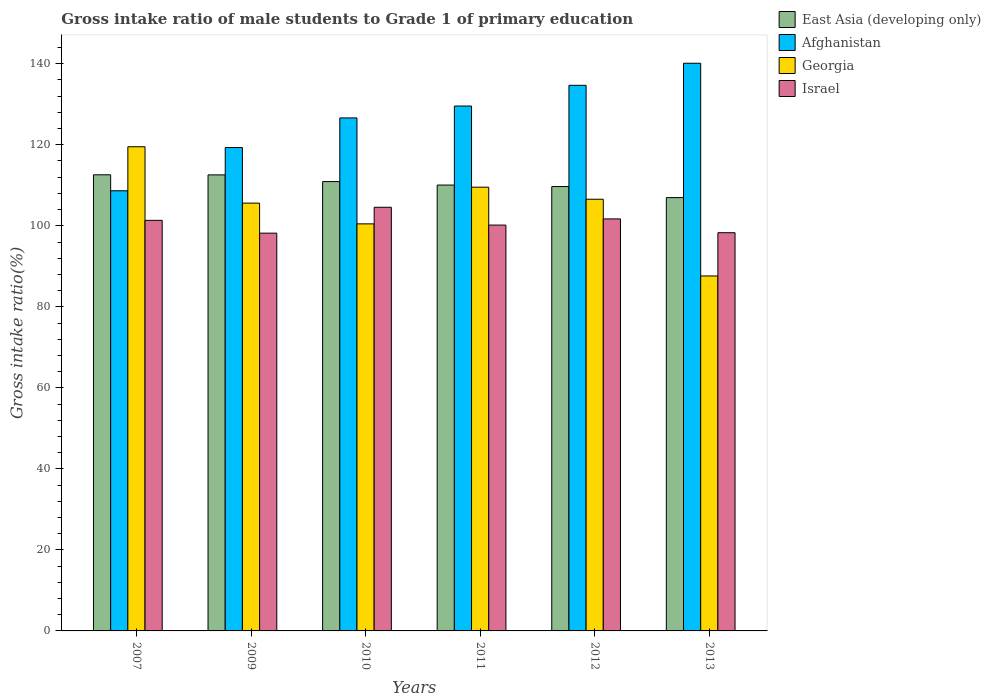How many different coloured bars are there?
Provide a succinct answer. 4. How many groups of bars are there?
Keep it short and to the point. 6. Are the number of bars per tick equal to the number of legend labels?
Ensure brevity in your answer.  Yes. Are the number of bars on each tick of the X-axis equal?
Keep it short and to the point. Yes. How many bars are there on the 1st tick from the right?
Provide a short and direct response. 4. What is the gross intake ratio in Georgia in 2012?
Make the answer very short. 106.55. Across all years, what is the maximum gross intake ratio in Israel?
Offer a very short reply. 104.58. Across all years, what is the minimum gross intake ratio in Afghanistan?
Offer a very short reply. 108.65. What is the total gross intake ratio in Georgia in the graph?
Offer a terse response. 629.29. What is the difference between the gross intake ratio in Afghanistan in 2009 and that in 2012?
Offer a terse response. -15.37. What is the difference between the gross intake ratio in East Asia (developing only) in 2007 and the gross intake ratio in Georgia in 2010?
Keep it short and to the point. 12.12. What is the average gross intake ratio in Israel per year?
Give a very brief answer. 100.71. In the year 2012, what is the difference between the gross intake ratio in East Asia (developing only) and gross intake ratio in Afghanistan?
Your response must be concise. -24.99. In how many years, is the gross intake ratio in East Asia (developing only) greater than 12 %?
Offer a terse response. 6. What is the ratio of the gross intake ratio in Afghanistan in 2007 to that in 2009?
Your answer should be compact. 0.91. Is the gross intake ratio in Afghanistan in 2007 less than that in 2009?
Make the answer very short. Yes. Is the difference between the gross intake ratio in East Asia (developing only) in 2007 and 2009 greater than the difference between the gross intake ratio in Afghanistan in 2007 and 2009?
Provide a succinct answer. Yes. What is the difference between the highest and the second highest gross intake ratio in Israel?
Give a very brief answer. 2.87. What is the difference between the highest and the lowest gross intake ratio in East Asia (developing only)?
Give a very brief answer. 5.64. In how many years, is the gross intake ratio in Afghanistan greater than the average gross intake ratio in Afghanistan taken over all years?
Ensure brevity in your answer.  4. Is the sum of the gross intake ratio in Afghanistan in 2012 and 2013 greater than the maximum gross intake ratio in East Asia (developing only) across all years?
Your answer should be very brief. Yes. What does the 4th bar from the right in 2011 represents?
Offer a terse response. East Asia (developing only). Does the graph contain any zero values?
Your answer should be very brief. No. Does the graph contain grids?
Offer a very short reply. No. What is the title of the graph?
Provide a succinct answer. Gross intake ratio of male students to Grade 1 of primary education. Does "Vietnam" appear as one of the legend labels in the graph?
Offer a terse response. No. What is the label or title of the Y-axis?
Offer a very short reply. Gross intake ratio(%). What is the Gross intake ratio(%) of East Asia (developing only) in 2007?
Provide a succinct answer. 112.59. What is the Gross intake ratio(%) in Afghanistan in 2007?
Provide a succinct answer. 108.65. What is the Gross intake ratio(%) of Georgia in 2007?
Provide a short and direct response. 119.51. What is the Gross intake ratio(%) of Israel in 2007?
Provide a short and direct response. 101.34. What is the Gross intake ratio(%) of East Asia (developing only) in 2009?
Your answer should be very brief. 112.57. What is the Gross intake ratio(%) in Afghanistan in 2009?
Keep it short and to the point. 119.31. What is the Gross intake ratio(%) in Georgia in 2009?
Ensure brevity in your answer.  105.6. What is the Gross intake ratio(%) of Israel in 2009?
Provide a succinct answer. 98.19. What is the Gross intake ratio(%) in East Asia (developing only) in 2010?
Offer a very short reply. 110.91. What is the Gross intake ratio(%) in Afghanistan in 2010?
Offer a terse response. 126.63. What is the Gross intake ratio(%) in Georgia in 2010?
Offer a terse response. 100.48. What is the Gross intake ratio(%) in Israel in 2010?
Your answer should be compact. 104.58. What is the Gross intake ratio(%) of East Asia (developing only) in 2011?
Provide a succinct answer. 110.06. What is the Gross intake ratio(%) in Afghanistan in 2011?
Offer a terse response. 129.57. What is the Gross intake ratio(%) in Georgia in 2011?
Offer a very short reply. 109.53. What is the Gross intake ratio(%) in Israel in 2011?
Keep it short and to the point. 100.18. What is the Gross intake ratio(%) of East Asia (developing only) in 2012?
Keep it short and to the point. 109.69. What is the Gross intake ratio(%) in Afghanistan in 2012?
Your answer should be very brief. 134.68. What is the Gross intake ratio(%) of Georgia in 2012?
Provide a succinct answer. 106.55. What is the Gross intake ratio(%) of Israel in 2012?
Give a very brief answer. 101.7. What is the Gross intake ratio(%) in East Asia (developing only) in 2013?
Ensure brevity in your answer.  106.96. What is the Gross intake ratio(%) in Afghanistan in 2013?
Keep it short and to the point. 140.12. What is the Gross intake ratio(%) in Georgia in 2013?
Make the answer very short. 87.62. What is the Gross intake ratio(%) of Israel in 2013?
Provide a succinct answer. 98.29. Across all years, what is the maximum Gross intake ratio(%) of East Asia (developing only)?
Make the answer very short. 112.59. Across all years, what is the maximum Gross intake ratio(%) of Afghanistan?
Your answer should be very brief. 140.12. Across all years, what is the maximum Gross intake ratio(%) in Georgia?
Your response must be concise. 119.51. Across all years, what is the maximum Gross intake ratio(%) of Israel?
Make the answer very short. 104.58. Across all years, what is the minimum Gross intake ratio(%) of East Asia (developing only)?
Your response must be concise. 106.96. Across all years, what is the minimum Gross intake ratio(%) of Afghanistan?
Your answer should be compact. 108.65. Across all years, what is the minimum Gross intake ratio(%) of Georgia?
Your response must be concise. 87.62. Across all years, what is the minimum Gross intake ratio(%) in Israel?
Ensure brevity in your answer.  98.19. What is the total Gross intake ratio(%) in East Asia (developing only) in the graph?
Provide a succinct answer. 662.77. What is the total Gross intake ratio(%) of Afghanistan in the graph?
Provide a short and direct response. 758.96. What is the total Gross intake ratio(%) in Georgia in the graph?
Provide a short and direct response. 629.29. What is the total Gross intake ratio(%) of Israel in the graph?
Provide a short and direct response. 604.28. What is the difference between the Gross intake ratio(%) of East Asia (developing only) in 2007 and that in 2009?
Ensure brevity in your answer.  0.02. What is the difference between the Gross intake ratio(%) in Afghanistan in 2007 and that in 2009?
Provide a short and direct response. -10.67. What is the difference between the Gross intake ratio(%) of Georgia in 2007 and that in 2009?
Provide a short and direct response. 13.91. What is the difference between the Gross intake ratio(%) of Israel in 2007 and that in 2009?
Provide a succinct answer. 3.16. What is the difference between the Gross intake ratio(%) in East Asia (developing only) in 2007 and that in 2010?
Your response must be concise. 1.68. What is the difference between the Gross intake ratio(%) of Afghanistan in 2007 and that in 2010?
Provide a short and direct response. -17.98. What is the difference between the Gross intake ratio(%) in Georgia in 2007 and that in 2010?
Ensure brevity in your answer.  19.04. What is the difference between the Gross intake ratio(%) of Israel in 2007 and that in 2010?
Keep it short and to the point. -3.23. What is the difference between the Gross intake ratio(%) of East Asia (developing only) in 2007 and that in 2011?
Offer a very short reply. 2.54. What is the difference between the Gross intake ratio(%) of Afghanistan in 2007 and that in 2011?
Provide a succinct answer. -20.92. What is the difference between the Gross intake ratio(%) of Georgia in 2007 and that in 2011?
Your answer should be compact. 9.98. What is the difference between the Gross intake ratio(%) in Israel in 2007 and that in 2011?
Make the answer very short. 1.16. What is the difference between the Gross intake ratio(%) of East Asia (developing only) in 2007 and that in 2012?
Provide a succinct answer. 2.91. What is the difference between the Gross intake ratio(%) of Afghanistan in 2007 and that in 2012?
Your answer should be compact. -26.03. What is the difference between the Gross intake ratio(%) in Georgia in 2007 and that in 2012?
Keep it short and to the point. 12.96. What is the difference between the Gross intake ratio(%) of Israel in 2007 and that in 2012?
Ensure brevity in your answer.  -0.36. What is the difference between the Gross intake ratio(%) of East Asia (developing only) in 2007 and that in 2013?
Give a very brief answer. 5.64. What is the difference between the Gross intake ratio(%) in Afghanistan in 2007 and that in 2013?
Make the answer very short. -31.47. What is the difference between the Gross intake ratio(%) in Georgia in 2007 and that in 2013?
Offer a terse response. 31.89. What is the difference between the Gross intake ratio(%) in Israel in 2007 and that in 2013?
Ensure brevity in your answer.  3.05. What is the difference between the Gross intake ratio(%) in East Asia (developing only) in 2009 and that in 2010?
Provide a short and direct response. 1.66. What is the difference between the Gross intake ratio(%) in Afghanistan in 2009 and that in 2010?
Your response must be concise. -7.32. What is the difference between the Gross intake ratio(%) in Georgia in 2009 and that in 2010?
Provide a short and direct response. 5.12. What is the difference between the Gross intake ratio(%) of Israel in 2009 and that in 2010?
Ensure brevity in your answer.  -6.39. What is the difference between the Gross intake ratio(%) of East Asia (developing only) in 2009 and that in 2011?
Give a very brief answer. 2.51. What is the difference between the Gross intake ratio(%) of Afghanistan in 2009 and that in 2011?
Provide a succinct answer. -10.25. What is the difference between the Gross intake ratio(%) of Georgia in 2009 and that in 2011?
Give a very brief answer. -3.94. What is the difference between the Gross intake ratio(%) of Israel in 2009 and that in 2011?
Offer a very short reply. -1.99. What is the difference between the Gross intake ratio(%) in East Asia (developing only) in 2009 and that in 2012?
Ensure brevity in your answer.  2.88. What is the difference between the Gross intake ratio(%) of Afghanistan in 2009 and that in 2012?
Your response must be concise. -15.37. What is the difference between the Gross intake ratio(%) of Georgia in 2009 and that in 2012?
Offer a very short reply. -0.95. What is the difference between the Gross intake ratio(%) of Israel in 2009 and that in 2012?
Your response must be concise. -3.51. What is the difference between the Gross intake ratio(%) of East Asia (developing only) in 2009 and that in 2013?
Provide a short and direct response. 5.61. What is the difference between the Gross intake ratio(%) of Afghanistan in 2009 and that in 2013?
Provide a short and direct response. -20.81. What is the difference between the Gross intake ratio(%) of Georgia in 2009 and that in 2013?
Provide a short and direct response. 17.98. What is the difference between the Gross intake ratio(%) in Israel in 2009 and that in 2013?
Give a very brief answer. -0.11. What is the difference between the Gross intake ratio(%) in East Asia (developing only) in 2010 and that in 2011?
Provide a succinct answer. 0.86. What is the difference between the Gross intake ratio(%) of Afghanistan in 2010 and that in 2011?
Your response must be concise. -2.94. What is the difference between the Gross intake ratio(%) in Georgia in 2010 and that in 2011?
Give a very brief answer. -9.06. What is the difference between the Gross intake ratio(%) in Israel in 2010 and that in 2011?
Your response must be concise. 4.39. What is the difference between the Gross intake ratio(%) in East Asia (developing only) in 2010 and that in 2012?
Give a very brief answer. 1.23. What is the difference between the Gross intake ratio(%) in Afghanistan in 2010 and that in 2012?
Your answer should be very brief. -8.05. What is the difference between the Gross intake ratio(%) of Georgia in 2010 and that in 2012?
Provide a short and direct response. -6.08. What is the difference between the Gross intake ratio(%) of Israel in 2010 and that in 2012?
Offer a terse response. 2.87. What is the difference between the Gross intake ratio(%) in East Asia (developing only) in 2010 and that in 2013?
Your response must be concise. 3.96. What is the difference between the Gross intake ratio(%) in Afghanistan in 2010 and that in 2013?
Make the answer very short. -13.49. What is the difference between the Gross intake ratio(%) in Georgia in 2010 and that in 2013?
Your answer should be very brief. 12.86. What is the difference between the Gross intake ratio(%) of Israel in 2010 and that in 2013?
Offer a very short reply. 6.28. What is the difference between the Gross intake ratio(%) in East Asia (developing only) in 2011 and that in 2012?
Make the answer very short. 0.37. What is the difference between the Gross intake ratio(%) of Afghanistan in 2011 and that in 2012?
Your answer should be compact. -5.11. What is the difference between the Gross intake ratio(%) of Georgia in 2011 and that in 2012?
Keep it short and to the point. 2.98. What is the difference between the Gross intake ratio(%) in Israel in 2011 and that in 2012?
Keep it short and to the point. -1.52. What is the difference between the Gross intake ratio(%) in East Asia (developing only) in 2011 and that in 2013?
Your answer should be very brief. 3.1. What is the difference between the Gross intake ratio(%) in Afghanistan in 2011 and that in 2013?
Make the answer very short. -10.56. What is the difference between the Gross intake ratio(%) in Georgia in 2011 and that in 2013?
Your response must be concise. 21.92. What is the difference between the Gross intake ratio(%) of Israel in 2011 and that in 2013?
Give a very brief answer. 1.89. What is the difference between the Gross intake ratio(%) in East Asia (developing only) in 2012 and that in 2013?
Provide a short and direct response. 2.73. What is the difference between the Gross intake ratio(%) of Afghanistan in 2012 and that in 2013?
Give a very brief answer. -5.44. What is the difference between the Gross intake ratio(%) in Georgia in 2012 and that in 2013?
Your response must be concise. 18.94. What is the difference between the Gross intake ratio(%) of Israel in 2012 and that in 2013?
Offer a terse response. 3.41. What is the difference between the Gross intake ratio(%) in East Asia (developing only) in 2007 and the Gross intake ratio(%) in Afghanistan in 2009?
Give a very brief answer. -6.72. What is the difference between the Gross intake ratio(%) of East Asia (developing only) in 2007 and the Gross intake ratio(%) of Georgia in 2009?
Provide a succinct answer. 6.99. What is the difference between the Gross intake ratio(%) of East Asia (developing only) in 2007 and the Gross intake ratio(%) of Israel in 2009?
Offer a terse response. 14.41. What is the difference between the Gross intake ratio(%) in Afghanistan in 2007 and the Gross intake ratio(%) in Georgia in 2009?
Provide a short and direct response. 3.05. What is the difference between the Gross intake ratio(%) in Afghanistan in 2007 and the Gross intake ratio(%) in Israel in 2009?
Make the answer very short. 10.46. What is the difference between the Gross intake ratio(%) of Georgia in 2007 and the Gross intake ratio(%) of Israel in 2009?
Ensure brevity in your answer.  21.33. What is the difference between the Gross intake ratio(%) in East Asia (developing only) in 2007 and the Gross intake ratio(%) in Afghanistan in 2010?
Provide a succinct answer. -14.04. What is the difference between the Gross intake ratio(%) of East Asia (developing only) in 2007 and the Gross intake ratio(%) of Georgia in 2010?
Your answer should be compact. 12.12. What is the difference between the Gross intake ratio(%) in East Asia (developing only) in 2007 and the Gross intake ratio(%) in Israel in 2010?
Keep it short and to the point. 8.02. What is the difference between the Gross intake ratio(%) of Afghanistan in 2007 and the Gross intake ratio(%) of Georgia in 2010?
Keep it short and to the point. 8.17. What is the difference between the Gross intake ratio(%) in Afghanistan in 2007 and the Gross intake ratio(%) in Israel in 2010?
Your response must be concise. 4.07. What is the difference between the Gross intake ratio(%) of Georgia in 2007 and the Gross intake ratio(%) of Israel in 2010?
Offer a very short reply. 14.94. What is the difference between the Gross intake ratio(%) in East Asia (developing only) in 2007 and the Gross intake ratio(%) in Afghanistan in 2011?
Your response must be concise. -16.97. What is the difference between the Gross intake ratio(%) of East Asia (developing only) in 2007 and the Gross intake ratio(%) of Georgia in 2011?
Your answer should be very brief. 3.06. What is the difference between the Gross intake ratio(%) in East Asia (developing only) in 2007 and the Gross intake ratio(%) in Israel in 2011?
Ensure brevity in your answer.  12.41. What is the difference between the Gross intake ratio(%) in Afghanistan in 2007 and the Gross intake ratio(%) in Georgia in 2011?
Your answer should be compact. -0.89. What is the difference between the Gross intake ratio(%) in Afghanistan in 2007 and the Gross intake ratio(%) in Israel in 2011?
Your answer should be very brief. 8.47. What is the difference between the Gross intake ratio(%) in Georgia in 2007 and the Gross intake ratio(%) in Israel in 2011?
Provide a succinct answer. 19.33. What is the difference between the Gross intake ratio(%) of East Asia (developing only) in 2007 and the Gross intake ratio(%) of Afghanistan in 2012?
Provide a short and direct response. -22.09. What is the difference between the Gross intake ratio(%) of East Asia (developing only) in 2007 and the Gross intake ratio(%) of Georgia in 2012?
Make the answer very short. 6.04. What is the difference between the Gross intake ratio(%) in East Asia (developing only) in 2007 and the Gross intake ratio(%) in Israel in 2012?
Provide a short and direct response. 10.89. What is the difference between the Gross intake ratio(%) of Afghanistan in 2007 and the Gross intake ratio(%) of Georgia in 2012?
Provide a short and direct response. 2.09. What is the difference between the Gross intake ratio(%) in Afghanistan in 2007 and the Gross intake ratio(%) in Israel in 2012?
Your answer should be very brief. 6.95. What is the difference between the Gross intake ratio(%) in Georgia in 2007 and the Gross intake ratio(%) in Israel in 2012?
Make the answer very short. 17.81. What is the difference between the Gross intake ratio(%) of East Asia (developing only) in 2007 and the Gross intake ratio(%) of Afghanistan in 2013?
Your answer should be very brief. -27.53. What is the difference between the Gross intake ratio(%) of East Asia (developing only) in 2007 and the Gross intake ratio(%) of Georgia in 2013?
Offer a very short reply. 24.97. What is the difference between the Gross intake ratio(%) of East Asia (developing only) in 2007 and the Gross intake ratio(%) of Israel in 2013?
Make the answer very short. 14.3. What is the difference between the Gross intake ratio(%) in Afghanistan in 2007 and the Gross intake ratio(%) in Georgia in 2013?
Give a very brief answer. 21.03. What is the difference between the Gross intake ratio(%) of Afghanistan in 2007 and the Gross intake ratio(%) of Israel in 2013?
Provide a short and direct response. 10.35. What is the difference between the Gross intake ratio(%) of Georgia in 2007 and the Gross intake ratio(%) of Israel in 2013?
Make the answer very short. 21.22. What is the difference between the Gross intake ratio(%) in East Asia (developing only) in 2009 and the Gross intake ratio(%) in Afghanistan in 2010?
Keep it short and to the point. -14.06. What is the difference between the Gross intake ratio(%) of East Asia (developing only) in 2009 and the Gross intake ratio(%) of Georgia in 2010?
Offer a very short reply. 12.09. What is the difference between the Gross intake ratio(%) of East Asia (developing only) in 2009 and the Gross intake ratio(%) of Israel in 2010?
Give a very brief answer. 7.99. What is the difference between the Gross intake ratio(%) of Afghanistan in 2009 and the Gross intake ratio(%) of Georgia in 2010?
Ensure brevity in your answer.  18.84. What is the difference between the Gross intake ratio(%) in Afghanistan in 2009 and the Gross intake ratio(%) in Israel in 2010?
Ensure brevity in your answer.  14.74. What is the difference between the Gross intake ratio(%) in Georgia in 2009 and the Gross intake ratio(%) in Israel in 2010?
Provide a succinct answer. 1.02. What is the difference between the Gross intake ratio(%) of East Asia (developing only) in 2009 and the Gross intake ratio(%) of Afghanistan in 2011?
Make the answer very short. -17. What is the difference between the Gross intake ratio(%) in East Asia (developing only) in 2009 and the Gross intake ratio(%) in Georgia in 2011?
Offer a very short reply. 3.04. What is the difference between the Gross intake ratio(%) of East Asia (developing only) in 2009 and the Gross intake ratio(%) of Israel in 2011?
Ensure brevity in your answer.  12.39. What is the difference between the Gross intake ratio(%) of Afghanistan in 2009 and the Gross intake ratio(%) of Georgia in 2011?
Your answer should be very brief. 9.78. What is the difference between the Gross intake ratio(%) of Afghanistan in 2009 and the Gross intake ratio(%) of Israel in 2011?
Make the answer very short. 19.13. What is the difference between the Gross intake ratio(%) of Georgia in 2009 and the Gross intake ratio(%) of Israel in 2011?
Your answer should be very brief. 5.42. What is the difference between the Gross intake ratio(%) of East Asia (developing only) in 2009 and the Gross intake ratio(%) of Afghanistan in 2012?
Provide a succinct answer. -22.11. What is the difference between the Gross intake ratio(%) in East Asia (developing only) in 2009 and the Gross intake ratio(%) in Georgia in 2012?
Provide a short and direct response. 6.02. What is the difference between the Gross intake ratio(%) in East Asia (developing only) in 2009 and the Gross intake ratio(%) in Israel in 2012?
Provide a succinct answer. 10.87. What is the difference between the Gross intake ratio(%) of Afghanistan in 2009 and the Gross intake ratio(%) of Georgia in 2012?
Provide a short and direct response. 12.76. What is the difference between the Gross intake ratio(%) of Afghanistan in 2009 and the Gross intake ratio(%) of Israel in 2012?
Your answer should be compact. 17.61. What is the difference between the Gross intake ratio(%) in Georgia in 2009 and the Gross intake ratio(%) in Israel in 2012?
Ensure brevity in your answer.  3.9. What is the difference between the Gross intake ratio(%) in East Asia (developing only) in 2009 and the Gross intake ratio(%) in Afghanistan in 2013?
Keep it short and to the point. -27.55. What is the difference between the Gross intake ratio(%) of East Asia (developing only) in 2009 and the Gross intake ratio(%) of Georgia in 2013?
Your response must be concise. 24.95. What is the difference between the Gross intake ratio(%) of East Asia (developing only) in 2009 and the Gross intake ratio(%) of Israel in 2013?
Your response must be concise. 14.27. What is the difference between the Gross intake ratio(%) of Afghanistan in 2009 and the Gross intake ratio(%) of Georgia in 2013?
Your answer should be compact. 31.69. What is the difference between the Gross intake ratio(%) of Afghanistan in 2009 and the Gross intake ratio(%) of Israel in 2013?
Your answer should be very brief. 21.02. What is the difference between the Gross intake ratio(%) of Georgia in 2009 and the Gross intake ratio(%) of Israel in 2013?
Your answer should be very brief. 7.3. What is the difference between the Gross intake ratio(%) of East Asia (developing only) in 2010 and the Gross intake ratio(%) of Afghanistan in 2011?
Your answer should be compact. -18.65. What is the difference between the Gross intake ratio(%) in East Asia (developing only) in 2010 and the Gross intake ratio(%) in Georgia in 2011?
Provide a short and direct response. 1.38. What is the difference between the Gross intake ratio(%) in East Asia (developing only) in 2010 and the Gross intake ratio(%) in Israel in 2011?
Your response must be concise. 10.73. What is the difference between the Gross intake ratio(%) in Afghanistan in 2010 and the Gross intake ratio(%) in Georgia in 2011?
Your response must be concise. 17.09. What is the difference between the Gross intake ratio(%) of Afghanistan in 2010 and the Gross intake ratio(%) of Israel in 2011?
Keep it short and to the point. 26.45. What is the difference between the Gross intake ratio(%) of Georgia in 2010 and the Gross intake ratio(%) of Israel in 2011?
Offer a very short reply. 0.29. What is the difference between the Gross intake ratio(%) in East Asia (developing only) in 2010 and the Gross intake ratio(%) in Afghanistan in 2012?
Your answer should be very brief. -23.77. What is the difference between the Gross intake ratio(%) of East Asia (developing only) in 2010 and the Gross intake ratio(%) of Georgia in 2012?
Make the answer very short. 4.36. What is the difference between the Gross intake ratio(%) of East Asia (developing only) in 2010 and the Gross intake ratio(%) of Israel in 2012?
Your answer should be compact. 9.21. What is the difference between the Gross intake ratio(%) of Afghanistan in 2010 and the Gross intake ratio(%) of Georgia in 2012?
Your answer should be very brief. 20.07. What is the difference between the Gross intake ratio(%) of Afghanistan in 2010 and the Gross intake ratio(%) of Israel in 2012?
Keep it short and to the point. 24.93. What is the difference between the Gross intake ratio(%) of Georgia in 2010 and the Gross intake ratio(%) of Israel in 2012?
Make the answer very short. -1.23. What is the difference between the Gross intake ratio(%) in East Asia (developing only) in 2010 and the Gross intake ratio(%) in Afghanistan in 2013?
Offer a very short reply. -29.21. What is the difference between the Gross intake ratio(%) of East Asia (developing only) in 2010 and the Gross intake ratio(%) of Georgia in 2013?
Ensure brevity in your answer.  23.29. What is the difference between the Gross intake ratio(%) in East Asia (developing only) in 2010 and the Gross intake ratio(%) in Israel in 2013?
Ensure brevity in your answer.  12.62. What is the difference between the Gross intake ratio(%) in Afghanistan in 2010 and the Gross intake ratio(%) in Georgia in 2013?
Provide a succinct answer. 39.01. What is the difference between the Gross intake ratio(%) of Afghanistan in 2010 and the Gross intake ratio(%) of Israel in 2013?
Offer a very short reply. 28.33. What is the difference between the Gross intake ratio(%) in Georgia in 2010 and the Gross intake ratio(%) in Israel in 2013?
Keep it short and to the point. 2.18. What is the difference between the Gross intake ratio(%) in East Asia (developing only) in 2011 and the Gross intake ratio(%) in Afghanistan in 2012?
Your answer should be very brief. -24.62. What is the difference between the Gross intake ratio(%) in East Asia (developing only) in 2011 and the Gross intake ratio(%) in Georgia in 2012?
Your response must be concise. 3.5. What is the difference between the Gross intake ratio(%) in East Asia (developing only) in 2011 and the Gross intake ratio(%) in Israel in 2012?
Your response must be concise. 8.36. What is the difference between the Gross intake ratio(%) of Afghanistan in 2011 and the Gross intake ratio(%) of Georgia in 2012?
Offer a terse response. 23.01. What is the difference between the Gross intake ratio(%) in Afghanistan in 2011 and the Gross intake ratio(%) in Israel in 2012?
Offer a terse response. 27.86. What is the difference between the Gross intake ratio(%) of Georgia in 2011 and the Gross intake ratio(%) of Israel in 2012?
Give a very brief answer. 7.83. What is the difference between the Gross intake ratio(%) in East Asia (developing only) in 2011 and the Gross intake ratio(%) in Afghanistan in 2013?
Provide a succinct answer. -30.06. What is the difference between the Gross intake ratio(%) in East Asia (developing only) in 2011 and the Gross intake ratio(%) in Georgia in 2013?
Your answer should be very brief. 22.44. What is the difference between the Gross intake ratio(%) of East Asia (developing only) in 2011 and the Gross intake ratio(%) of Israel in 2013?
Give a very brief answer. 11.76. What is the difference between the Gross intake ratio(%) of Afghanistan in 2011 and the Gross intake ratio(%) of Georgia in 2013?
Keep it short and to the point. 41.95. What is the difference between the Gross intake ratio(%) in Afghanistan in 2011 and the Gross intake ratio(%) in Israel in 2013?
Make the answer very short. 31.27. What is the difference between the Gross intake ratio(%) in Georgia in 2011 and the Gross intake ratio(%) in Israel in 2013?
Keep it short and to the point. 11.24. What is the difference between the Gross intake ratio(%) of East Asia (developing only) in 2012 and the Gross intake ratio(%) of Afghanistan in 2013?
Make the answer very short. -30.44. What is the difference between the Gross intake ratio(%) in East Asia (developing only) in 2012 and the Gross intake ratio(%) in Georgia in 2013?
Your answer should be very brief. 22.07. What is the difference between the Gross intake ratio(%) of East Asia (developing only) in 2012 and the Gross intake ratio(%) of Israel in 2013?
Provide a short and direct response. 11.39. What is the difference between the Gross intake ratio(%) in Afghanistan in 2012 and the Gross intake ratio(%) in Georgia in 2013?
Your answer should be very brief. 47.06. What is the difference between the Gross intake ratio(%) in Afghanistan in 2012 and the Gross intake ratio(%) in Israel in 2013?
Keep it short and to the point. 36.38. What is the difference between the Gross intake ratio(%) of Georgia in 2012 and the Gross intake ratio(%) of Israel in 2013?
Make the answer very short. 8.26. What is the average Gross intake ratio(%) of East Asia (developing only) per year?
Ensure brevity in your answer.  110.46. What is the average Gross intake ratio(%) in Afghanistan per year?
Your response must be concise. 126.49. What is the average Gross intake ratio(%) in Georgia per year?
Your response must be concise. 104.88. What is the average Gross intake ratio(%) in Israel per year?
Offer a terse response. 100.71. In the year 2007, what is the difference between the Gross intake ratio(%) of East Asia (developing only) and Gross intake ratio(%) of Afghanistan?
Ensure brevity in your answer.  3.95. In the year 2007, what is the difference between the Gross intake ratio(%) in East Asia (developing only) and Gross intake ratio(%) in Georgia?
Provide a succinct answer. -6.92. In the year 2007, what is the difference between the Gross intake ratio(%) of East Asia (developing only) and Gross intake ratio(%) of Israel?
Your response must be concise. 11.25. In the year 2007, what is the difference between the Gross intake ratio(%) in Afghanistan and Gross intake ratio(%) in Georgia?
Make the answer very short. -10.86. In the year 2007, what is the difference between the Gross intake ratio(%) of Afghanistan and Gross intake ratio(%) of Israel?
Offer a terse response. 7.3. In the year 2007, what is the difference between the Gross intake ratio(%) in Georgia and Gross intake ratio(%) in Israel?
Your answer should be compact. 18.17. In the year 2009, what is the difference between the Gross intake ratio(%) in East Asia (developing only) and Gross intake ratio(%) in Afghanistan?
Provide a short and direct response. -6.74. In the year 2009, what is the difference between the Gross intake ratio(%) in East Asia (developing only) and Gross intake ratio(%) in Georgia?
Make the answer very short. 6.97. In the year 2009, what is the difference between the Gross intake ratio(%) in East Asia (developing only) and Gross intake ratio(%) in Israel?
Your answer should be very brief. 14.38. In the year 2009, what is the difference between the Gross intake ratio(%) of Afghanistan and Gross intake ratio(%) of Georgia?
Ensure brevity in your answer.  13.71. In the year 2009, what is the difference between the Gross intake ratio(%) in Afghanistan and Gross intake ratio(%) in Israel?
Keep it short and to the point. 21.13. In the year 2009, what is the difference between the Gross intake ratio(%) in Georgia and Gross intake ratio(%) in Israel?
Give a very brief answer. 7.41. In the year 2010, what is the difference between the Gross intake ratio(%) of East Asia (developing only) and Gross intake ratio(%) of Afghanistan?
Keep it short and to the point. -15.72. In the year 2010, what is the difference between the Gross intake ratio(%) in East Asia (developing only) and Gross intake ratio(%) in Georgia?
Your answer should be compact. 10.44. In the year 2010, what is the difference between the Gross intake ratio(%) of East Asia (developing only) and Gross intake ratio(%) of Israel?
Your response must be concise. 6.34. In the year 2010, what is the difference between the Gross intake ratio(%) of Afghanistan and Gross intake ratio(%) of Georgia?
Offer a very short reply. 26.15. In the year 2010, what is the difference between the Gross intake ratio(%) of Afghanistan and Gross intake ratio(%) of Israel?
Your answer should be very brief. 22.05. In the year 2010, what is the difference between the Gross intake ratio(%) in Georgia and Gross intake ratio(%) in Israel?
Offer a very short reply. -4.1. In the year 2011, what is the difference between the Gross intake ratio(%) in East Asia (developing only) and Gross intake ratio(%) in Afghanistan?
Offer a very short reply. -19.51. In the year 2011, what is the difference between the Gross intake ratio(%) of East Asia (developing only) and Gross intake ratio(%) of Georgia?
Provide a succinct answer. 0.52. In the year 2011, what is the difference between the Gross intake ratio(%) of East Asia (developing only) and Gross intake ratio(%) of Israel?
Offer a very short reply. 9.88. In the year 2011, what is the difference between the Gross intake ratio(%) of Afghanistan and Gross intake ratio(%) of Georgia?
Your response must be concise. 20.03. In the year 2011, what is the difference between the Gross intake ratio(%) in Afghanistan and Gross intake ratio(%) in Israel?
Give a very brief answer. 29.38. In the year 2011, what is the difference between the Gross intake ratio(%) of Georgia and Gross intake ratio(%) of Israel?
Your answer should be very brief. 9.35. In the year 2012, what is the difference between the Gross intake ratio(%) of East Asia (developing only) and Gross intake ratio(%) of Afghanistan?
Provide a succinct answer. -24.99. In the year 2012, what is the difference between the Gross intake ratio(%) of East Asia (developing only) and Gross intake ratio(%) of Georgia?
Keep it short and to the point. 3.13. In the year 2012, what is the difference between the Gross intake ratio(%) in East Asia (developing only) and Gross intake ratio(%) in Israel?
Your answer should be very brief. 7.98. In the year 2012, what is the difference between the Gross intake ratio(%) of Afghanistan and Gross intake ratio(%) of Georgia?
Make the answer very short. 28.12. In the year 2012, what is the difference between the Gross intake ratio(%) in Afghanistan and Gross intake ratio(%) in Israel?
Make the answer very short. 32.98. In the year 2012, what is the difference between the Gross intake ratio(%) of Georgia and Gross intake ratio(%) of Israel?
Offer a terse response. 4.85. In the year 2013, what is the difference between the Gross intake ratio(%) of East Asia (developing only) and Gross intake ratio(%) of Afghanistan?
Offer a terse response. -33.17. In the year 2013, what is the difference between the Gross intake ratio(%) in East Asia (developing only) and Gross intake ratio(%) in Georgia?
Give a very brief answer. 19.34. In the year 2013, what is the difference between the Gross intake ratio(%) in East Asia (developing only) and Gross intake ratio(%) in Israel?
Keep it short and to the point. 8.66. In the year 2013, what is the difference between the Gross intake ratio(%) of Afghanistan and Gross intake ratio(%) of Georgia?
Offer a terse response. 52.5. In the year 2013, what is the difference between the Gross intake ratio(%) in Afghanistan and Gross intake ratio(%) in Israel?
Offer a very short reply. 41.83. In the year 2013, what is the difference between the Gross intake ratio(%) in Georgia and Gross intake ratio(%) in Israel?
Ensure brevity in your answer.  -10.68. What is the ratio of the Gross intake ratio(%) in Afghanistan in 2007 to that in 2009?
Offer a very short reply. 0.91. What is the ratio of the Gross intake ratio(%) of Georgia in 2007 to that in 2009?
Your answer should be compact. 1.13. What is the ratio of the Gross intake ratio(%) of Israel in 2007 to that in 2009?
Ensure brevity in your answer.  1.03. What is the ratio of the Gross intake ratio(%) in East Asia (developing only) in 2007 to that in 2010?
Keep it short and to the point. 1.02. What is the ratio of the Gross intake ratio(%) of Afghanistan in 2007 to that in 2010?
Make the answer very short. 0.86. What is the ratio of the Gross intake ratio(%) of Georgia in 2007 to that in 2010?
Offer a very short reply. 1.19. What is the ratio of the Gross intake ratio(%) of Israel in 2007 to that in 2010?
Your answer should be very brief. 0.97. What is the ratio of the Gross intake ratio(%) in East Asia (developing only) in 2007 to that in 2011?
Keep it short and to the point. 1.02. What is the ratio of the Gross intake ratio(%) of Afghanistan in 2007 to that in 2011?
Provide a succinct answer. 0.84. What is the ratio of the Gross intake ratio(%) of Georgia in 2007 to that in 2011?
Your answer should be very brief. 1.09. What is the ratio of the Gross intake ratio(%) in Israel in 2007 to that in 2011?
Keep it short and to the point. 1.01. What is the ratio of the Gross intake ratio(%) in East Asia (developing only) in 2007 to that in 2012?
Your response must be concise. 1.03. What is the ratio of the Gross intake ratio(%) of Afghanistan in 2007 to that in 2012?
Ensure brevity in your answer.  0.81. What is the ratio of the Gross intake ratio(%) in Georgia in 2007 to that in 2012?
Your response must be concise. 1.12. What is the ratio of the Gross intake ratio(%) of Israel in 2007 to that in 2012?
Provide a short and direct response. 1. What is the ratio of the Gross intake ratio(%) of East Asia (developing only) in 2007 to that in 2013?
Ensure brevity in your answer.  1.05. What is the ratio of the Gross intake ratio(%) in Afghanistan in 2007 to that in 2013?
Offer a very short reply. 0.78. What is the ratio of the Gross intake ratio(%) of Georgia in 2007 to that in 2013?
Your answer should be compact. 1.36. What is the ratio of the Gross intake ratio(%) of Israel in 2007 to that in 2013?
Provide a short and direct response. 1.03. What is the ratio of the Gross intake ratio(%) of East Asia (developing only) in 2009 to that in 2010?
Ensure brevity in your answer.  1.01. What is the ratio of the Gross intake ratio(%) of Afghanistan in 2009 to that in 2010?
Your answer should be compact. 0.94. What is the ratio of the Gross intake ratio(%) of Georgia in 2009 to that in 2010?
Make the answer very short. 1.05. What is the ratio of the Gross intake ratio(%) in Israel in 2009 to that in 2010?
Provide a succinct answer. 0.94. What is the ratio of the Gross intake ratio(%) of East Asia (developing only) in 2009 to that in 2011?
Keep it short and to the point. 1.02. What is the ratio of the Gross intake ratio(%) of Afghanistan in 2009 to that in 2011?
Your response must be concise. 0.92. What is the ratio of the Gross intake ratio(%) in Georgia in 2009 to that in 2011?
Offer a very short reply. 0.96. What is the ratio of the Gross intake ratio(%) of Israel in 2009 to that in 2011?
Make the answer very short. 0.98. What is the ratio of the Gross intake ratio(%) in East Asia (developing only) in 2009 to that in 2012?
Offer a terse response. 1.03. What is the ratio of the Gross intake ratio(%) of Afghanistan in 2009 to that in 2012?
Provide a succinct answer. 0.89. What is the ratio of the Gross intake ratio(%) in Georgia in 2009 to that in 2012?
Provide a succinct answer. 0.99. What is the ratio of the Gross intake ratio(%) in Israel in 2009 to that in 2012?
Offer a terse response. 0.97. What is the ratio of the Gross intake ratio(%) in East Asia (developing only) in 2009 to that in 2013?
Make the answer very short. 1.05. What is the ratio of the Gross intake ratio(%) in Afghanistan in 2009 to that in 2013?
Keep it short and to the point. 0.85. What is the ratio of the Gross intake ratio(%) of Georgia in 2009 to that in 2013?
Your response must be concise. 1.21. What is the ratio of the Gross intake ratio(%) of East Asia (developing only) in 2010 to that in 2011?
Your answer should be compact. 1.01. What is the ratio of the Gross intake ratio(%) in Afghanistan in 2010 to that in 2011?
Provide a short and direct response. 0.98. What is the ratio of the Gross intake ratio(%) in Georgia in 2010 to that in 2011?
Your answer should be compact. 0.92. What is the ratio of the Gross intake ratio(%) in Israel in 2010 to that in 2011?
Offer a terse response. 1.04. What is the ratio of the Gross intake ratio(%) of East Asia (developing only) in 2010 to that in 2012?
Ensure brevity in your answer.  1.01. What is the ratio of the Gross intake ratio(%) of Afghanistan in 2010 to that in 2012?
Provide a short and direct response. 0.94. What is the ratio of the Gross intake ratio(%) of Georgia in 2010 to that in 2012?
Keep it short and to the point. 0.94. What is the ratio of the Gross intake ratio(%) in Israel in 2010 to that in 2012?
Make the answer very short. 1.03. What is the ratio of the Gross intake ratio(%) in Afghanistan in 2010 to that in 2013?
Ensure brevity in your answer.  0.9. What is the ratio of the Gross intake ratio(%) of Georgia in 2010 to that in 2013?
Give a very brief answer. 1.15. What is the ratio of the Gross intake ratio(%) in Israel in 2010 to that in 2013?
Your answer should be very brief. 1.06. What is the ratio of the Gross intake ratio(%) of East Asia (developing only) in 2011 to that in 2012?
Keep it short and to the point. 1. What is the ratio of the Gross intake ratio(%) in Georgia in 2011 to that in 2012?
Your answer should be very brief. 1.03. What is the ratio of the Gross intake ratio(%) of Israel in 2011 to that in 2012?
Make the answer very short. 0.99. What is the ratio of the Gross intake ratio(%) of East Asia (developing only) in 2011 to that in 2013?
Offer a terse response. 1.03. What is the ratio of the Gross intake ratio(%) of Afghanistan in 2011 to that in 2013?
Provide a short and direct response. 0.92. What is the ratio of the Gross intake ratio(%) of Georgia in 2011 to that in 2013?
Your response must be concise. 1.25. What is the ratio of the Gross intake ratio(%) of Israel in 2011 to that in 2013?
Make the answer very short. 1.02. What is the ratio of the Gross intake ratio(%) in East Asia (developing only) in 2012 to that in 2013?
Keep it short and to the point. 1.03. What is the ratio of the Gross intake ratio(%) in Afghanistan in 2012 to that in 2013?
Your answer should be compact. 0.96. What is the ratio of the Gross intake ratio(%) in Georgia in 2012 to that in 2013?
Make the answer very short. 1.22. What is the ratio of the Gross intake ratio(%) of Israel in 2012 to that in 2013?
Offer a very short reply. 1.03. What is the difference between the highest and the second highest Gross intake ratio(%) in East Asia (developing only)?
Provide a succinct answer. 0.02. What is the difference between the highest and the second highest Gross intake ratio(%) of Afghanistan?
Provide a short and direct response. 5.44. What is the difference between the highest and the second highest Gross intake ratio(%) of Georgia?
Offer a very short reply. 9.98. What is the difference between the highest and the second highest Gross intake ratio(%) of Israel?
Your response must be concise. 2.87. What is the difference between the highest and the lowest Gross intake ratio(%) in East Asia (developing only)?
Make the answer very short. 5.64. What is the difference between the highest and the lowest Gross intake ratio(%) of Afghanistan?
Offer a terse response. 31.47. What is the difference between the highest and the lowest Gross intake ratio(%) of Georgia?
Your response must be concise. 31.89. What is the difference between the highest and the lowest Gross intake ratio(%) of Israel?
Provide a succinct answer. 6.39. 